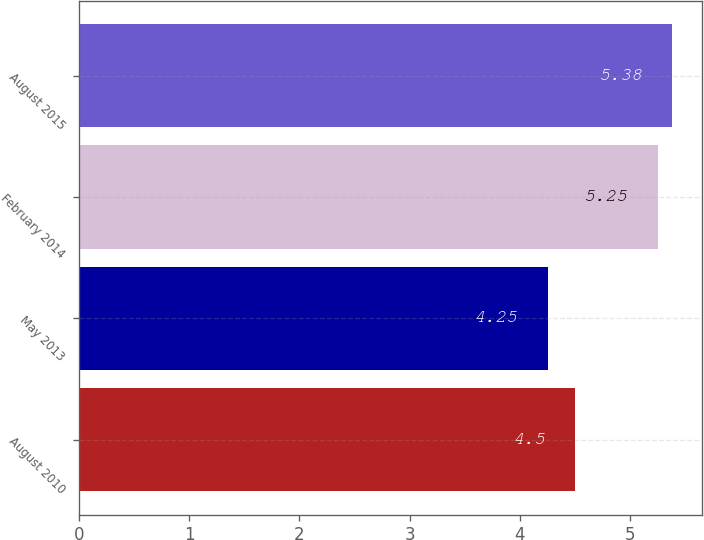<chart> <loc_0><loc_0><loc_500><loc_500><bar_chart><fcel>August 2010<fcel>May 2013<fcel>February 2014<fcel>August 2015<nl><fcel>4.5<fcel>4.25<fcel>5.25<fcel>5.38<nl></chart> 